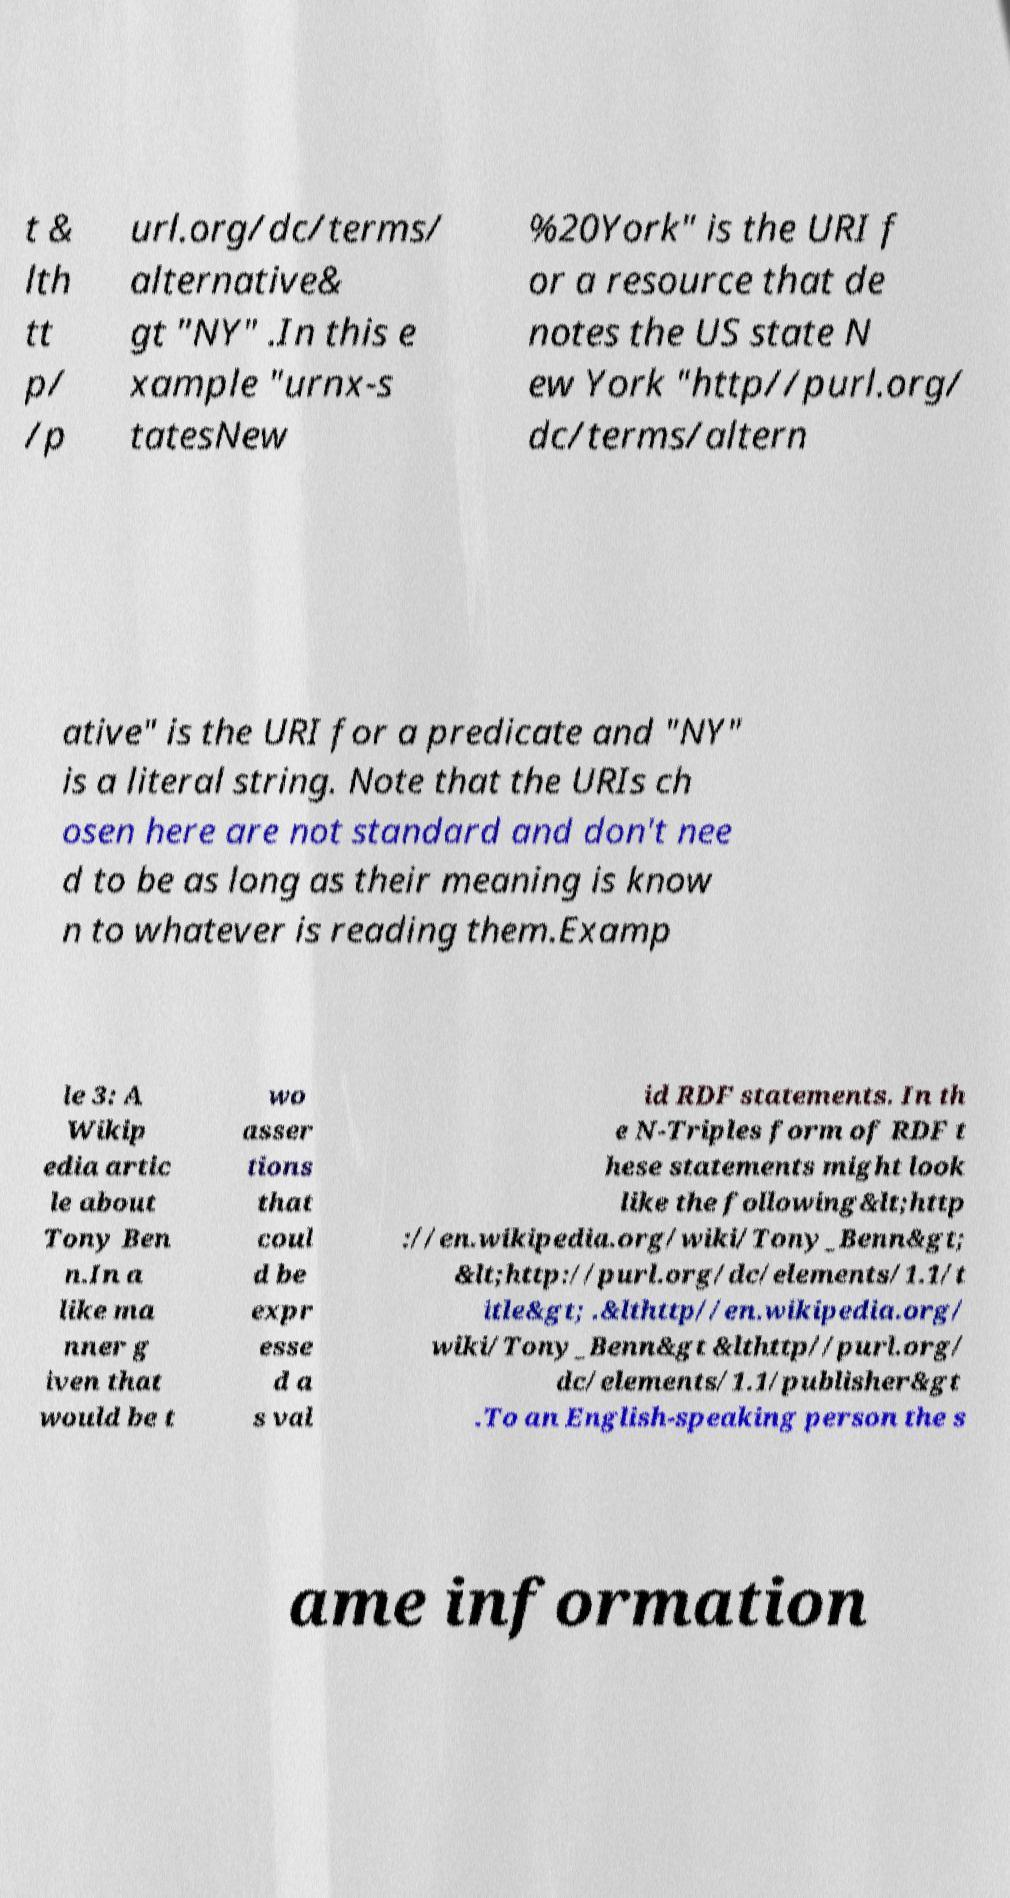What messages or text are displayed in this image? I need them in a readable, typed format. t & lth tt p/ /p url.org/dc/terms/ alternative& gt "NY" .In this e xample "urnx-s tatesNew %20York" is the URI f or a resource that de notes the US state N ew York "http//purl.org/ dc/terms/altern ative" is the URI for a predicate and "NY" is a literal string. Note that the URIs ch osen here are not standard and don't nee d to be as long as their meaning is know n to whatever is reading them.Examp le 3: A Wikip edia artic le about Tony Ben n.In a like ma nner g iven that would be t wo asser tions that coul d be expr esse d a s val id RDF statements. In th e N-Triples form of RDF t hese statements might look like the following&lt;http ://en.wikipedia.org/wiki/Tony_Benn&gt; &lt;http://purl.org/dc/elements/1.1/t itle&gt; .&lthttp//en.wikipedia.org/ wiki/Tony_Benn&gt &lthttp//purl.org/ dc/elements/1.1/publisher&gt .To an English-speaking person the s ame information 